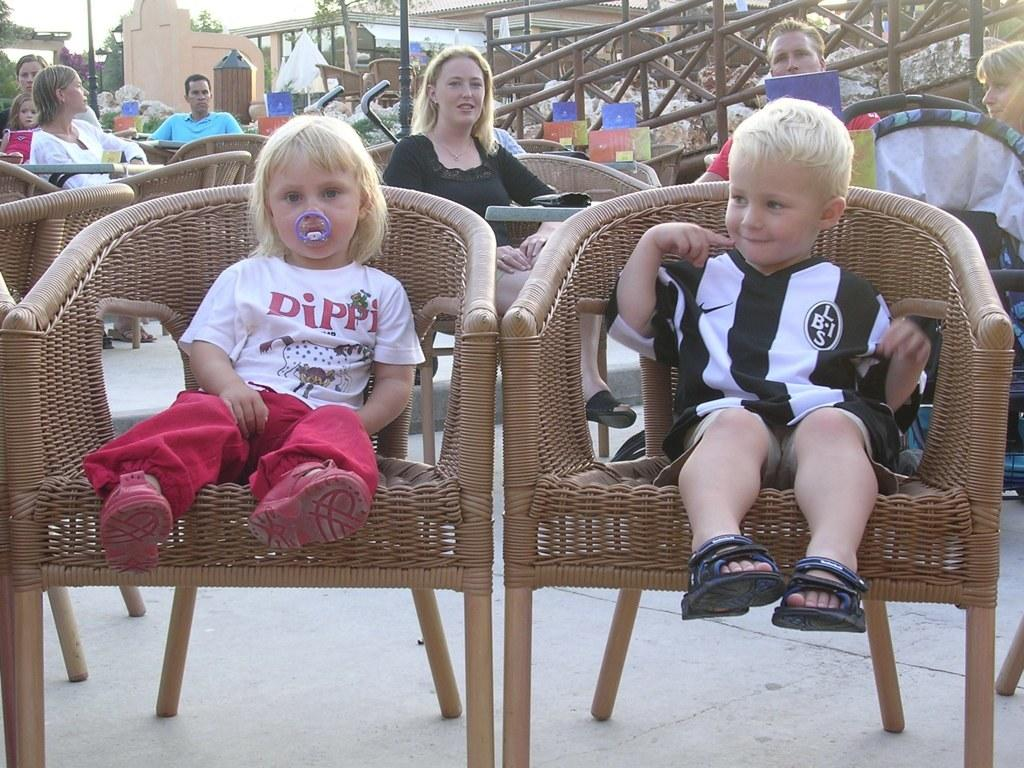What is happening in the image? There is a group of people in the image. How are the people positioned in the image? The people are seated on chairs. What can be seen in the background of the image? There are buildings and trees in the background of the image. What type of jam is being served to the monkey in the image? There is no monkey or jam present in the image. 